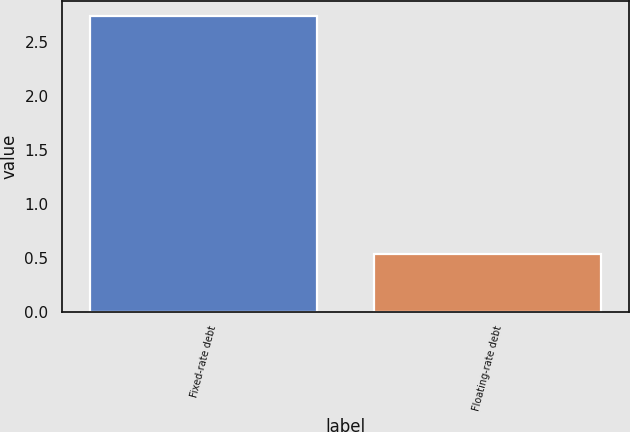Convert chart. <chart><loc_0><loc_0><loc_500><loc_500><bar_chart><fcel>Fixed-rate debt<fcel>Floating-rate debt<nl><fcel>2.74<fcel>0.53<nl></chart> 